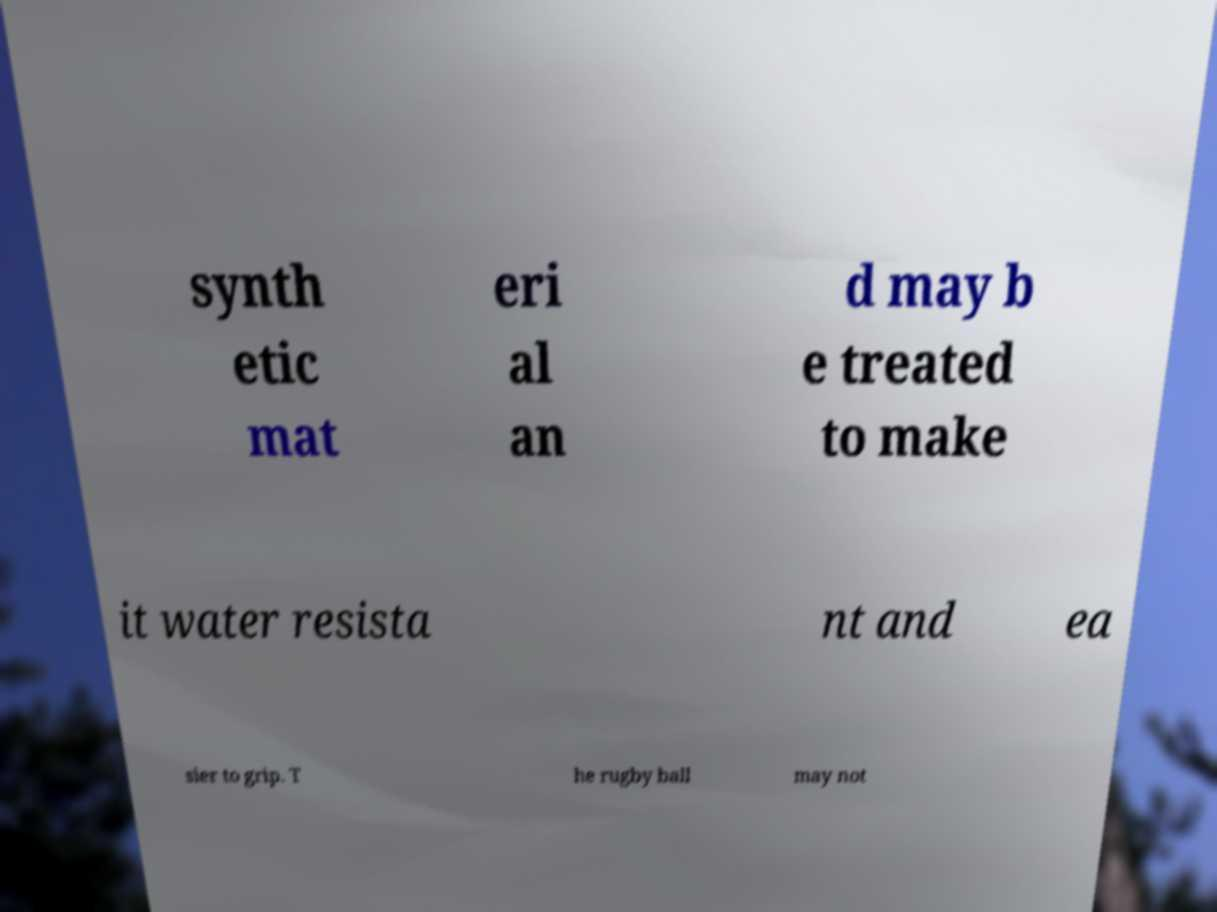Please read and relay the text visible in this image. What does it say? synth etic mat eri al an d may b e treated to make it water resista nt and ea sier to grip. T he rugby ball may not 